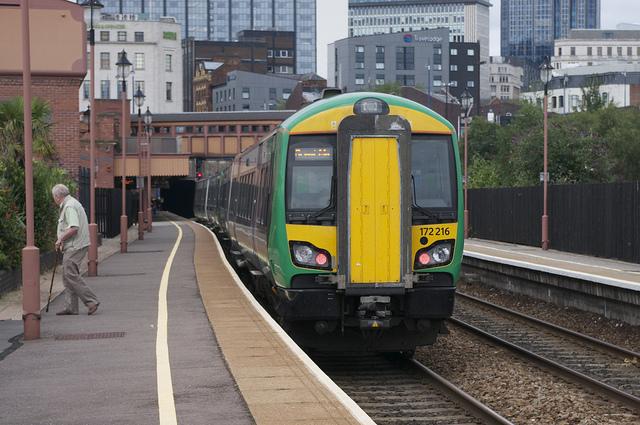What colors is the train?
Concise answer only. Green and yellow. How many people are standing on the train platform?
Answer briefly. 1. What numbers are on the train?
Be succinct. 172216. Which digits are repeated on the front of the train?
Answer briefly. 172216. 